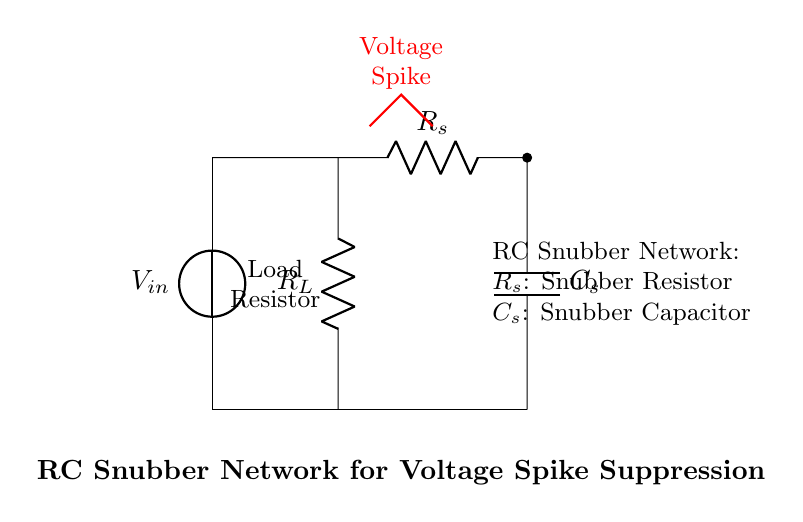What is the value of the load resistor? The load resistor is labeled as R_L in the circuit diagram; however, its value is not specified in the visual representation.
Answer: Not specified What components are included in the RC snubber network? The RC snubber network consists of a resistor labeled R_s and a capacitor labeled C_s, connected in series.
Answer: Resistor and Capacitor What does the red waveform represent in the circuit? The red waveform indicates a voltage spike occurring in the circuit, which the snubber network is designed to suppress.
Answer: Voltage spike How are the snubber resistor and capacitor connected in the circuit? The snubber resistor R_s is connected in series with the snubber capacitor C_s, forming a path from the main circuit to ground.
Answer: In series What is the purpose of the RC snubber network in this circuit? The RC snubber network is intended to suppress voltage spikes that can occur during switching operations within the power supply circuit.
Answer: Suppress voltage spikes What is the relationship between the snubber resistor and voltage spikes? The snubber resistor R_s dissipates energy from the voltage spikes, helping to reduce their amplitude before they affect the circuit components.
Answer: Dissipates energy What does the “*” indicate in the connection to the snubber resistor R_s? The “*” indicates a connection point that joins the resistor to the circuit, signifying the entry point of the snubber network into the main circuit for voltage spike protection.
Answer: Connection point 